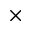<formula> <loc_0><loc_0><loc_500><loc_500>\times</formula> 